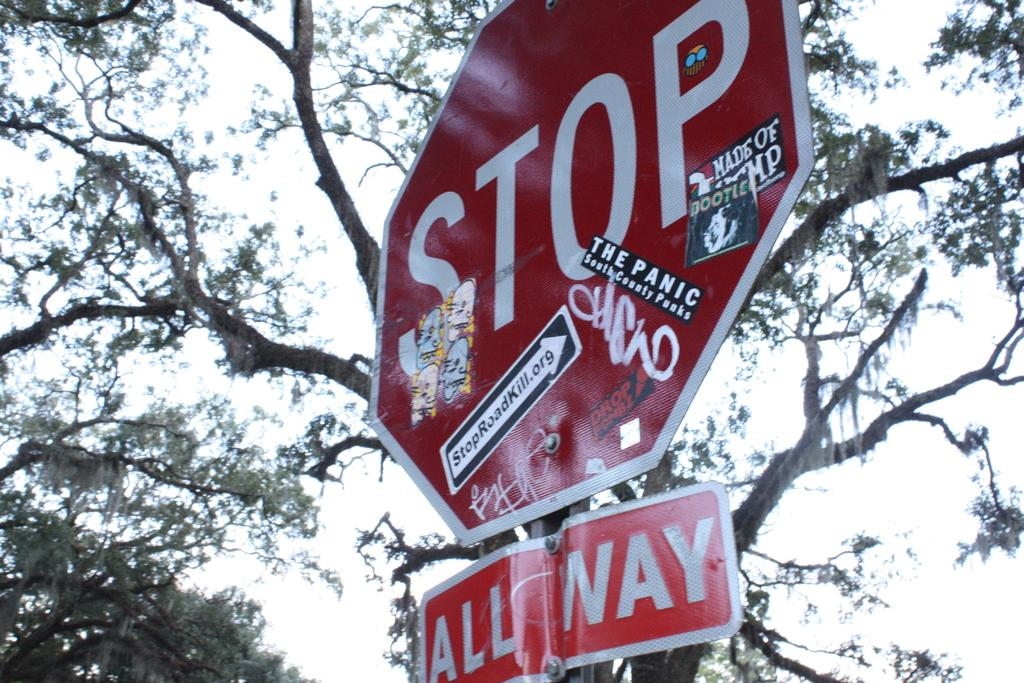<image>
Summarize the visual content of the image. A stop sign plastered with various stickers stands below a tree. 